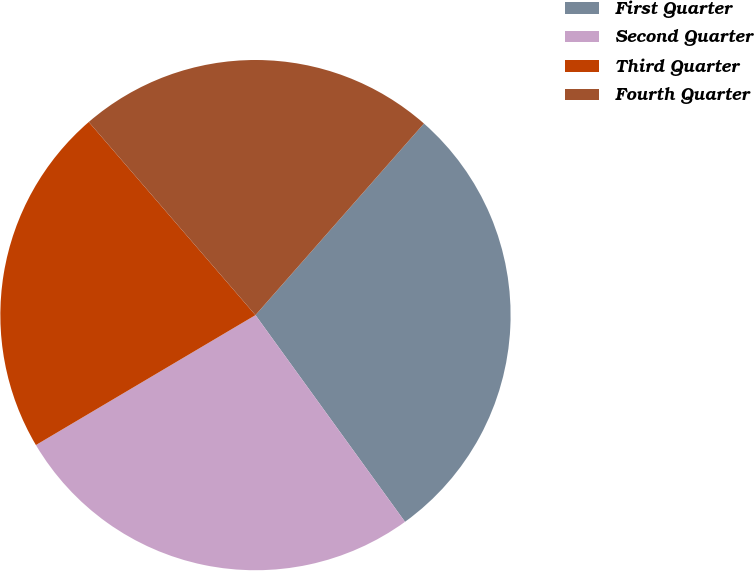Convert chart to OTSL. <chart><loc_0><loc_0><loc_500><loc_500><pie_chart><fcel>First Quarter<fcel>Second Quarter<fcel>Third Quarter<fcel>Fourth Quarter<nl><fcel>28.55%<fcel>26.46%<fcel>22.17%<fcel>22.81%<nl></chart> 